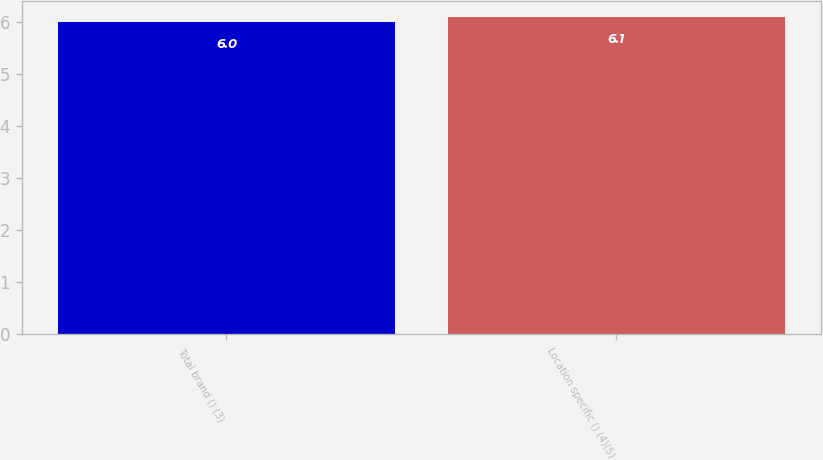Convert chart to OTSL. <chart><loc_0><loc_0><loc_500><loc_500><bar_chart><fcel>Total brand () (3)<fcel>Location specific () (4)(5)<nl><fcel>6<fcel>6.1<nl></chart> 